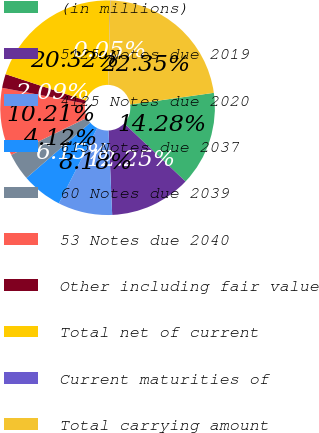Convert chart. <chart><loc_0><loc_0><loc_500><loc_500><pie_chart><fcel>(in millions)<fcel>5125 Notes due 2019<fcel>4125 Notes due 2020<fcel>615 Notes due 2037<fcel>60 Notes due 2039<fcel>53 Notes due 2040<fcel>Other including fair value<fcel>Total net of current<fcel>Current maturities of<fcel>Total carrying amount<nl><fcel>14.28%<fcel>12.25%<fcel>8.18%<fcel>6.15%<fcel>4.12%<fcel>10.21%<fcel>2.09%<fcel>20.32%<fcel>0.05%<fcel>22.35%<nl></chart> 